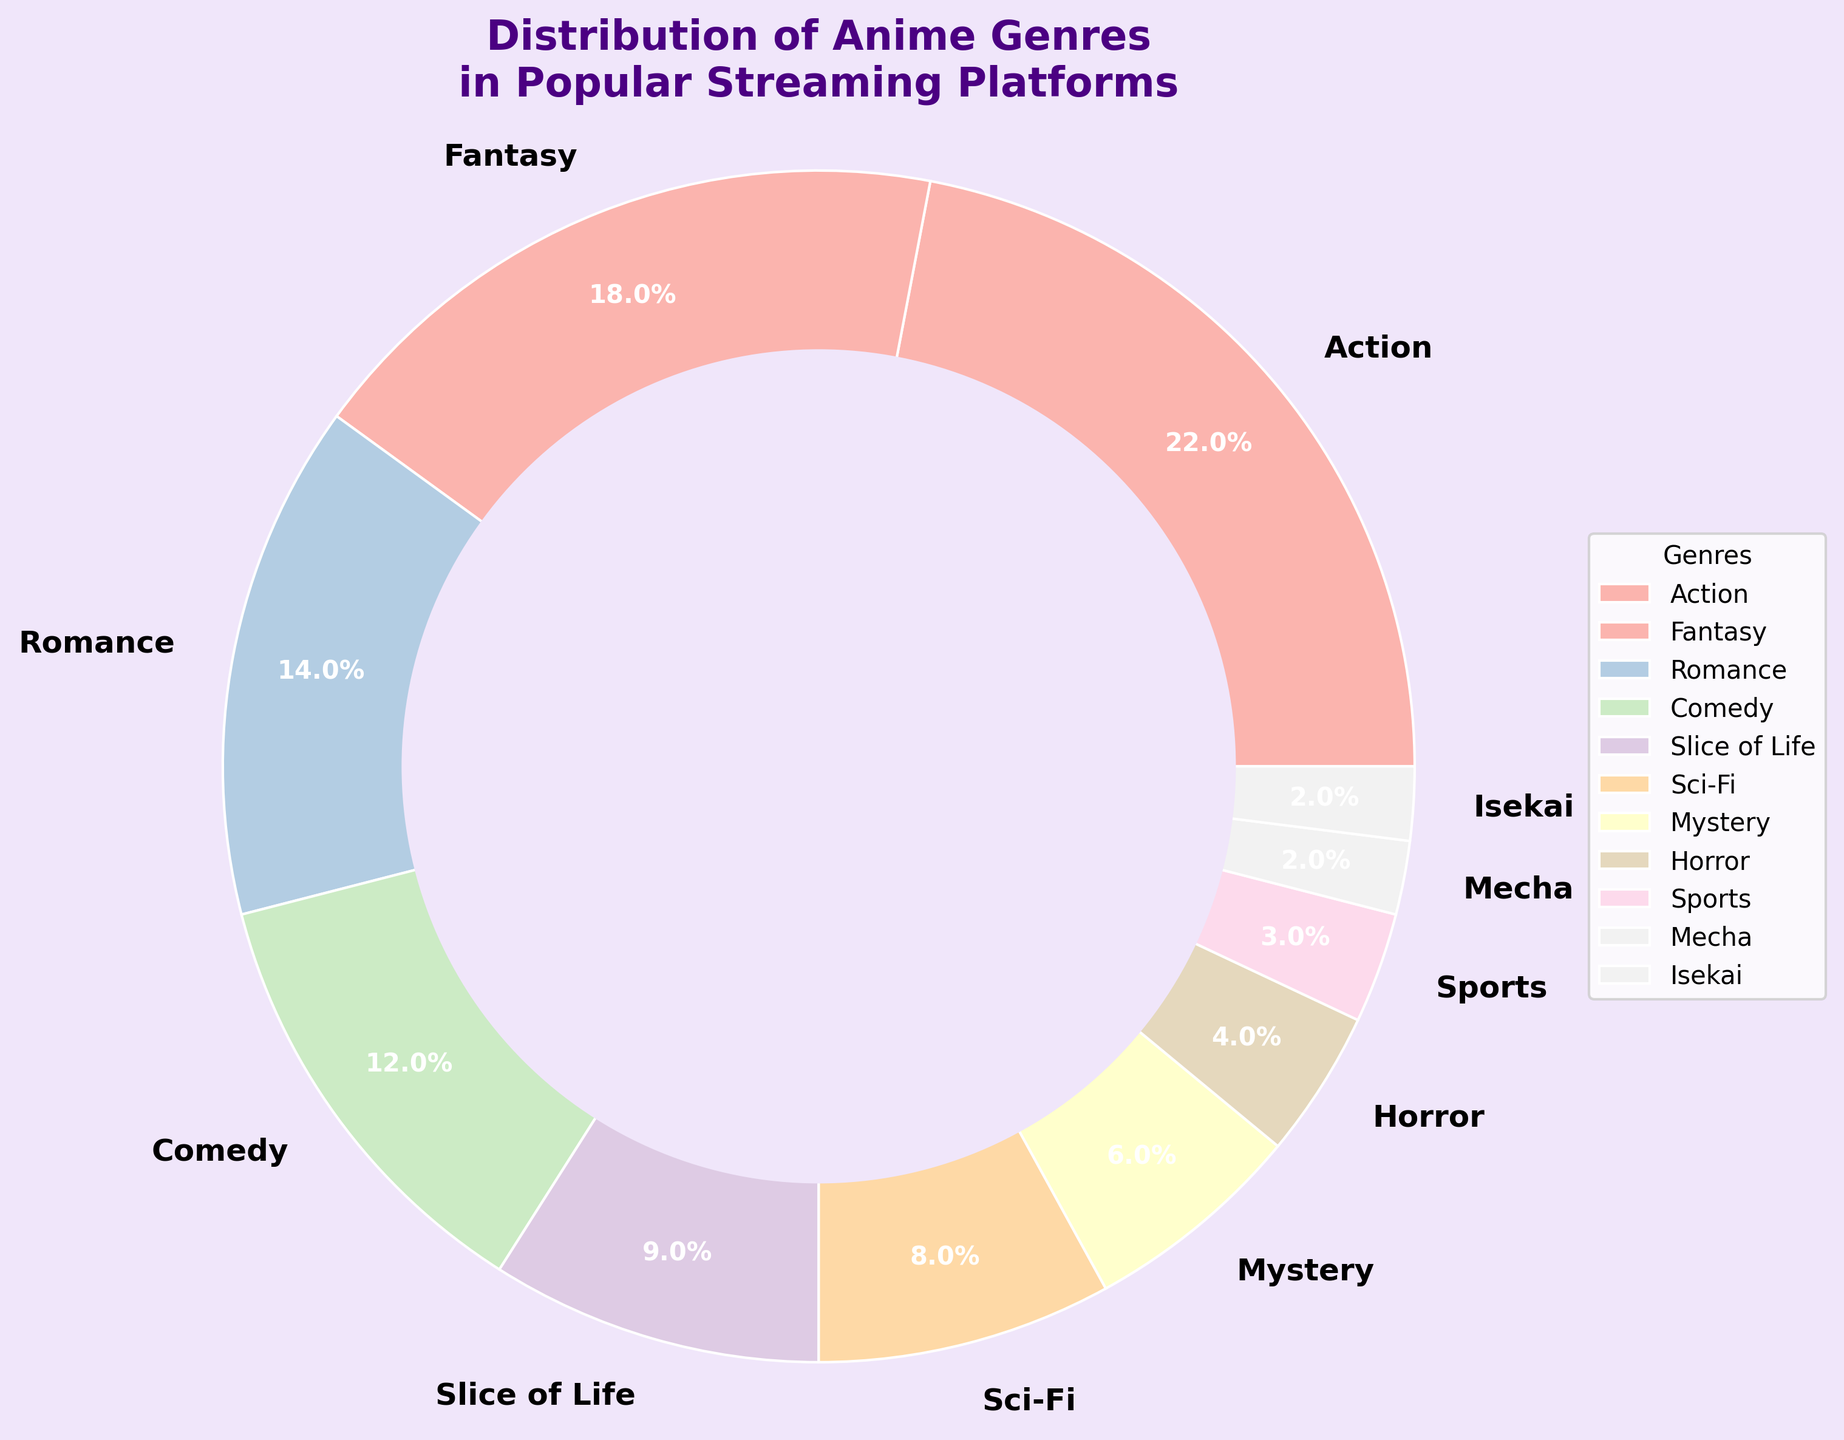What genre has the highest percentage? The genre with the largest segment in the pie chart is the one with the highest percentage. By looking at the chart, Action has the largest slice.
Answer: Action How much more percentage does the Action genre have compared to Romance? Subtract the percentage of Romance from the percentage of Action: 22% (Action) - 14% (Romance) = 8%.
Answer: 8% If you combine the percentages of Fantasy and Comedy, do they exceed the percentage of Action? Add the percentages of Fantasy and Comedy: 18% (Fantasy) + 12% (Comedy) = 30%. Then compare it to Action's percentage: 30% > 22%.
Answer: Yes What are the three least popular genres? Identify the genres with the smallest slices in the pie chart: Mecha (2%), Isekai (2%), and Sports (3%).
Answer: Mecha, Isekai, Sports How does the percentage of Sci-Fi compare to Slice of Life? Compare the percentages directly: 8% (Sci-Fi) vs. 9% (Slice of Life). Slice of Life has 1% more than Sci-Fi.
Answer: Slice of Life is 1% more What is the combined percentage of Mystery, Horror, and Mecha genres? Add the percentages of Mystery, Horror, and Mecha: 6% (Mystery) + 4% (Horror) + 2% (Mecha) = 12%.
Answer: 12% Which genre makes up almost a quarter of the pie chart? Identify the genre with a percentage close to 25%, which is the largest slice: Action with 22%.
Answer: Action Are there more genres with a percentage below 10% or above 10%? Count the genres below 10%: Slice of Life, Sci-Fi, Mystery, Horror, Sports, Mecha, Isekai (total 7), and compare with those above 10%: Action, Fantasy, Romance, Comedy (total 4).
Answer: Below 10% Which genres together equal the percentage of Fantasy? Combine genres until their total adds up to Fantasy's percentage (18%). For example, Comedy (12%) + Slice of Life (9%) = 21%, which is slightly more than 18%. Mystery (6%) + Horror (4%) + Sports (3%) + Mecha (2%) + Isekai (2%) = 17%, which is closest but less.
Answer: Mystery, Horror, Sports, Mecha, Isekai 